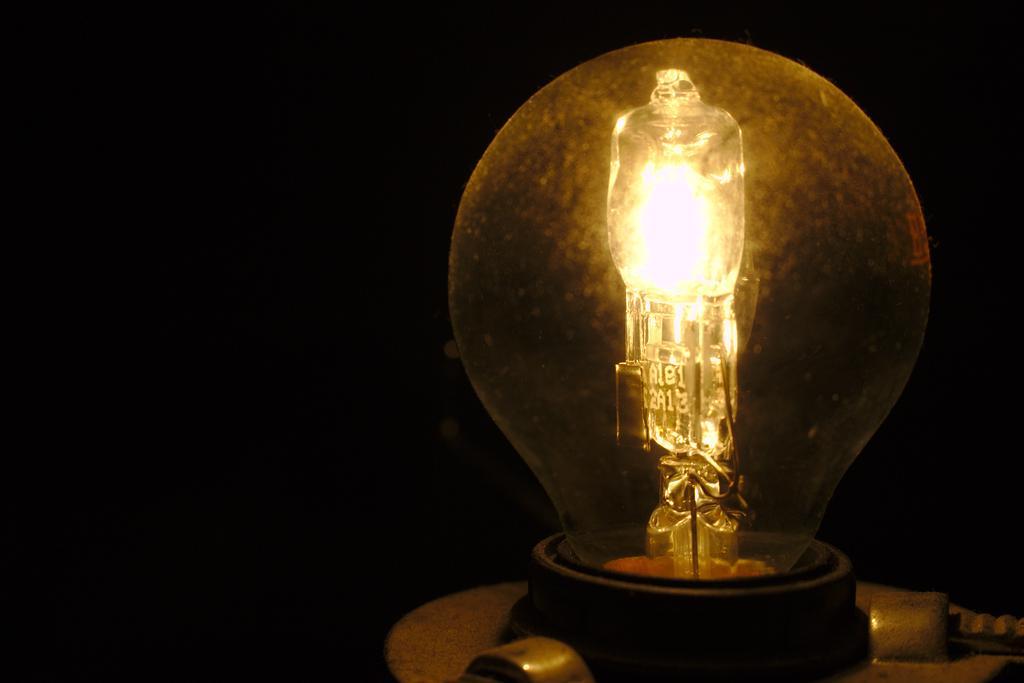In one or two sentences, can you explain what this image depicts? In this picture I can see a bulb and I can see dark background. 